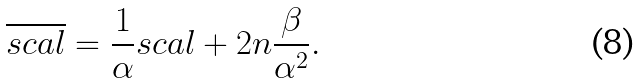Convert formula to latex. <formula><loc_0><loc_0><loc_500><loc_500>\overline { s c a l } = \frac { 1 } { \alpha } s c a l + 2 n \frac { \beta } { \alpha ^ { 2 } } .</formula> 